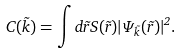Convert formula to latex. <formula><loc_0><loc_0><loc_500><loc_500>C ( \vec { k } ) = \int d \vec { r } S ( \vec { r } ) | \Psi _ { \vec { k } } ( \vec { r } ) | ^ { 2 } .</formula> 